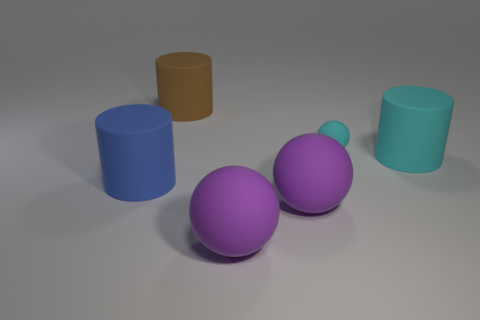Subtract all purple spheres. How many were subtracted if there are1purple spheres left? 1 Add 3 big gray metal balls. How many objects exist? 9 Subtract 2 cylinders. How many cylinders are left? 1 Subtract all purple rubber spheres. How many spheres are left? 1 Subtract all cyan balls. How many balls are left? 2 Subtract all green cylinders. Subtract all yellow balls. How many cylinders are left? 3 Subtract all green cylinders. How many purple balls are left? 2 Subtract all small cyan things. Subtract all big blue cylinders. How many objects are left? 4 Add 6 tiny cyan spheres. How many tiny cyan spheres are left? 7 Add 2 cyan spheres. How many cyan spheres exist? 3 